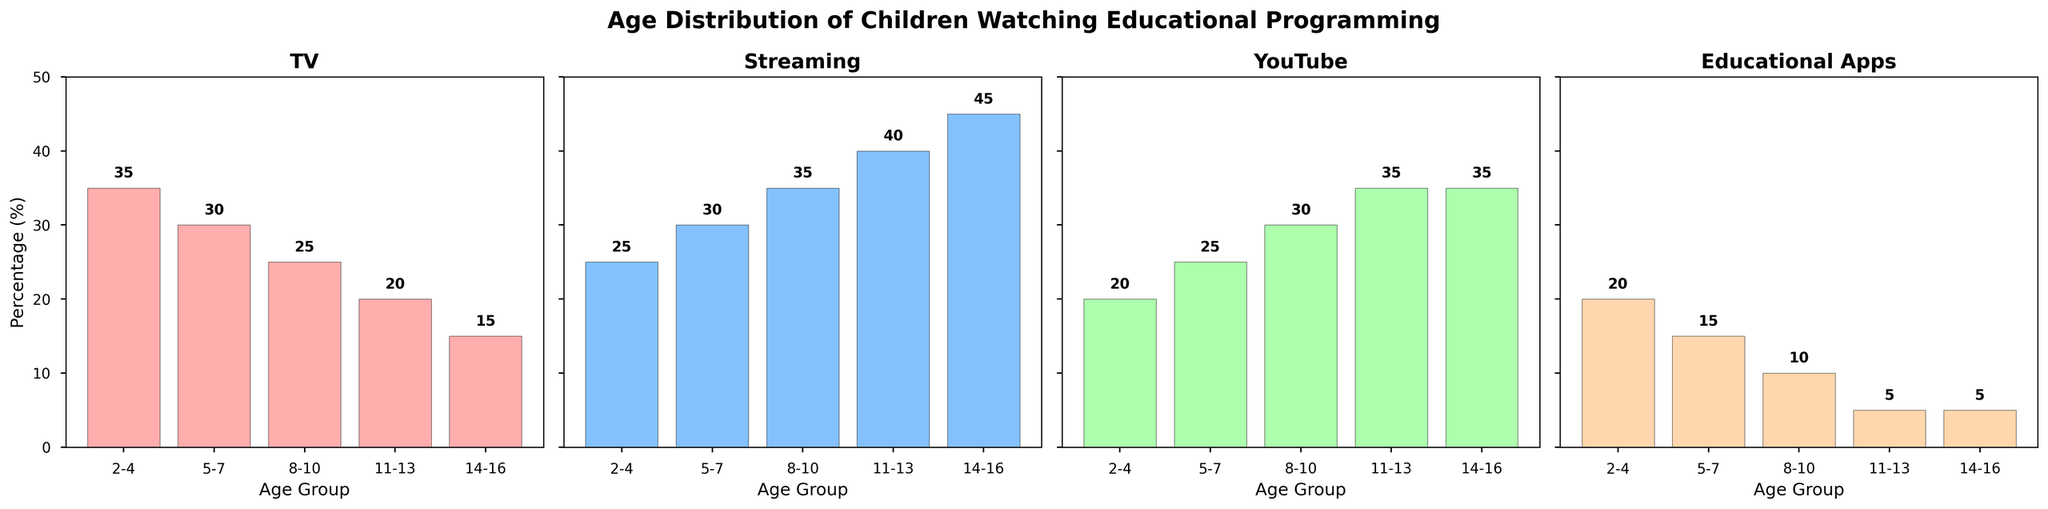Which age group watches TV the most? To determine which age group watches TV the most, observe the height of the bars in the TV subplot. The highest bar corresponds to the 2-4 age group with a percentage of 35%.
Answer: 2-4 Which platform has the highest percentage of viewers among 11-13 year-olds? To find out which platform has the highest percentage among 11-13 year-olds, compare the heights of the bars in the 11-13 age group across all subplots. Streaming has the tallest bar at 40%.
Answer: Streaming What is the difference in percentage between streaming and educational apps for 8-10 year-olds? To find the difference, subtract the percentage of educational apps from the percentage of streaming for the 8-10 age group. This is 35% (streaming) - 10% (educational apps) = 25%.
Answer: 25% How does the percentage of TV viewing change from the 2-4 age group to the 14-16 age group? To understand the change, compare the percentages of TV viewing for the 2-4 and 14-16 age groups. The 2-4 age group has 35%, and the 14-16 age group has 15%, so there is a decrease of 20%.
Answer: Decrease by 20% Which two platforms have equal percentages for the 14-16 age group? Compare the heights of the bars for the 14-16 age group in all subplots. Both YouTube and Educational Apps have a percentage of 5%.
Answer: YouTube and Educational Apps Across all age groups, which platform shows a consistent increase in viewership percentages? Examine the trend of each platform across age groups. Streaming shows a consistent increase from 25% for 2-4 years to 45% for 14-16 years.
Answer: Streaming What is the sum of the percentage of children using YouTube for the 2-4 and 5-7 age groups? Add the percentages of YouTube use for the 2-4 and 5-7 age groups. This is 20% + 25% = 45%.
Answer: 45% Which platform has the smallest range of percentages across all age groups? To find the range, subtract the lowest percentage from the highest for each platform. Educational Apps ranges from 20% to 5%, with a range of 20% - 5% = 15%. No other platform has a smaller range.
Answer: Educational Apps 